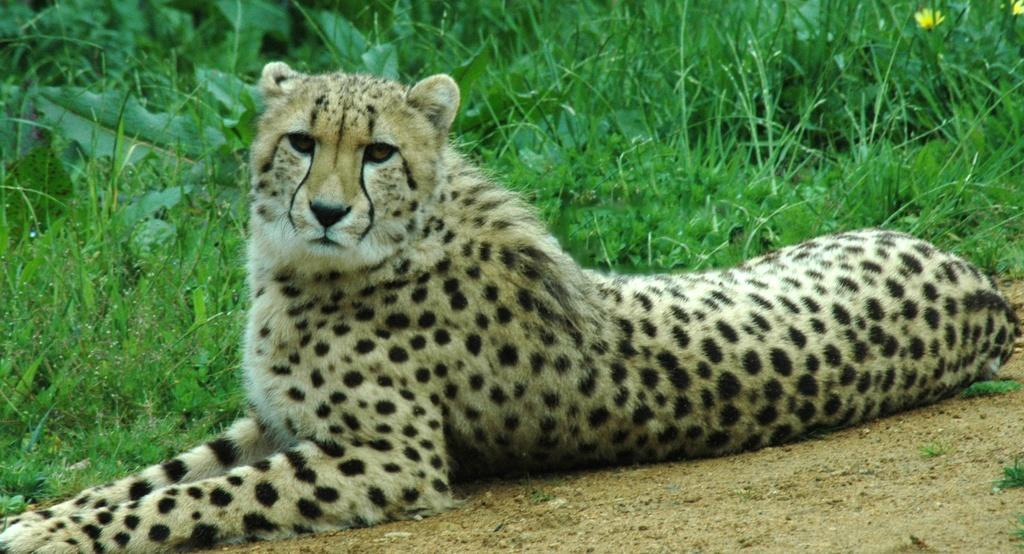What is the main subject of the image? There is a cheetah in the center of the image. Can you describe the color of the cheetah? The cheetah is black and cream in color. What can be seen in the background of the image? There is grass, flowers, and a few other objects in the background of the image. What type of condition does the cheetah have on its back in the image? There is no mention of any condition on the cheetah's back in the image. Can you see a comb in the image? There is no comb present in the image. 